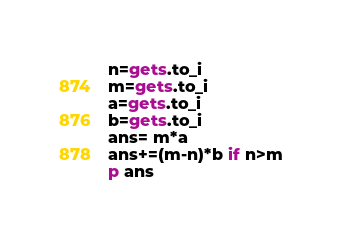<code> <loc_0><loc_0><loc_500><loc_500><_Ruby_>n=gets.to_i
m=gets.to_i
a=gets.to_i
b=gets.to_i
ans= m*a
ans+=(m-n)*b if n>m
p ans
</code> 